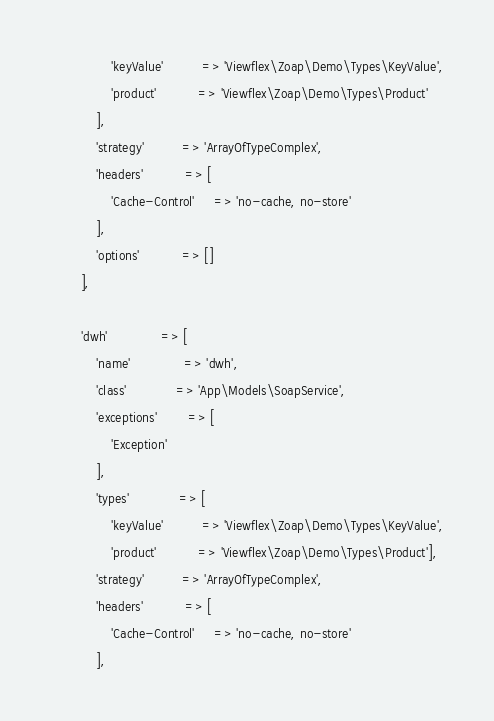Convert code to text. <code><loc_0><loc_0><loc_500><loc_500><_PHP_>                'keyValue'          => 'Viewflex\Zoap\Demo\Types\KeyValue',
                'product'           => 'Viewflex\Zoap\Demo\Types\Product'
            ],
            'strategy'          => 'ArrayOfTypeComplex',
            'headers'           => [
                'Cache-Control'     => 'no-cache, no-store'
            ],
            'options'           => []
        ],

        'dwh'              => [
            'name'              => 'dwh',
            'class'             => 'App\Models\SoapService',
            'exceptions'        => [
                'Exception'
            ],
            'types'             => [
                'keyValue'          => 'Viewflex\Zoap\Demo\Types\KeyValue',
                'product'           => 'Viewflex\Zoap\Demo\Types\Product'],
            'strategy'          => 'ArrayOfTypeComplex',
            'headers'           => [
                'Cache-Control'     => 'no-cache, no-store'
            ],</code> 